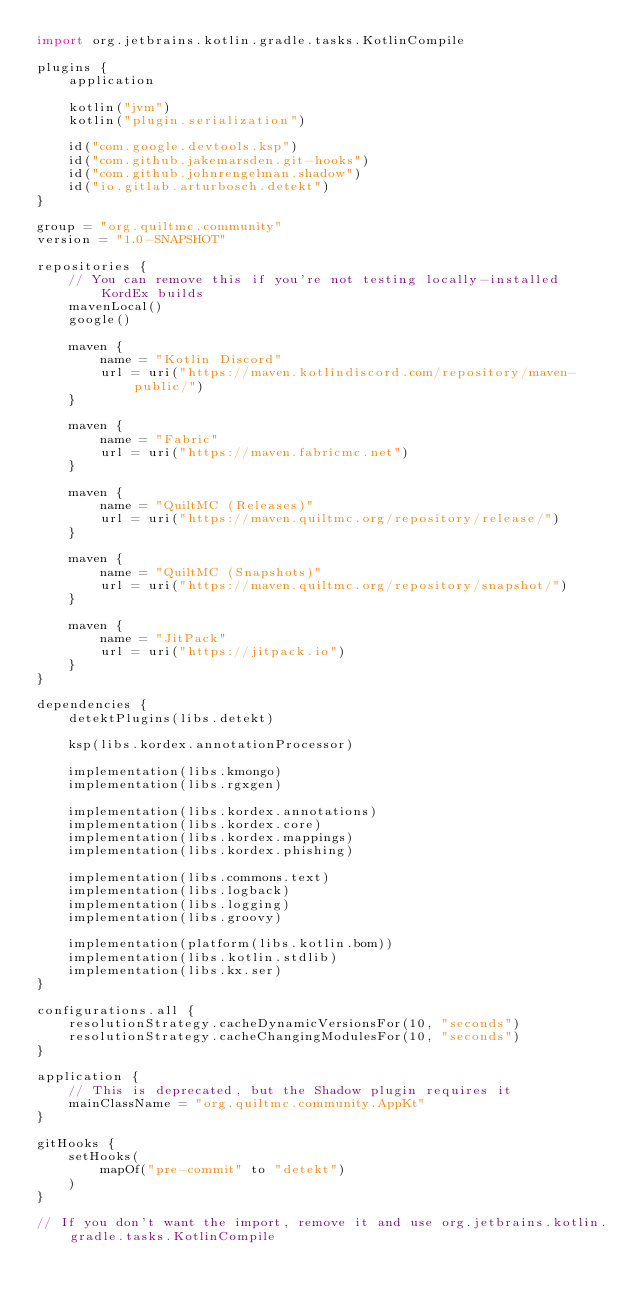<code> <loc_0><loc_0><loc_500><loc_500><_Kotlin_>import org.jetbrains.kotlin.gradle.tasks.KotlinCompile

plugins {
    application

    kotlin("jvm")
    kotlin("plugin.serialization")

    id("com.google.devtools.ksp")
    id("com.github.jakemarsden.git-hooks")
    id("com.github.johnrengelman.shadow")
    id("io.gitlab.arturbosch.detekt")
}

group = "org.quiltmc.community"
version = "1.0-SNAPSHOT"

repositories {
    // You can remove this if you're not testing locally-installed KordEx builds
    mavenLocal()
    google()

    maven {
        name = "Kotlin Discord"
        url = uri("https://maven.kotlindiscord.com/repository/maven-public/")
    }

    maven {
        name = "Fabric"
        url = uri("https://maven.fabricmc.net")
    }

    maven {
        name = "QuiltMC (Releases)"
        url = uri("https://maven.quiltmc.org/repository/release/")
    }

    maven {
        name = "QuiltMC (Snapshots)"
        url = uri("https://maven.quiltmc.org/repository/snapshot/")
    }

    maven {
        name = "JitPack"
        url = uri("https://jitpack.io")
    }
}

dependencies {
    detektPlugins(libs.detekt)

    ksp(libs.kordex.annotationProcessor)

    implementation(libs.kmongo)
    implementation(libs.rgxgen)

    implementation(libs.kordex.annotations)
    implementation(libs.kordex.core)
    implementation(libs.kordex.mappings)
    implementation(libs.kordex.phishing)

    implementation(libs.commons.text)
    implementation(libs.logback)
    implementation(libs.logging)
    implementation(libs.groovy)

    implementation(platform(libs.kotlin.bom))
    implementation(libs.kotlin.stdlib)
    implementation(libs.kx.ser)
}

configurations.all {
    resolutionStrategy.cacheDynamicVersionsFor(10, "seconds")
    resolutionStrategy.cacheChangingModulesFor(10, "seconds")
}

application {
    // This is deprecated, but the Shadow plugin requires it
    mainClassName = "org.quiltmc.community.AppKt"
}

gitHooks {
    setHooks(
        mapOf("pre-commit" to "detekt")
    )
}

// If you don't want the import, remove it and use org.jetbrains.kotlin.gradle.tasks.KotlinCompile</code> 